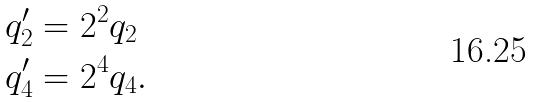Convert formula to latex. <formula><loc_0><loc_0><loc_500><loc_500>q _ { 2 } ^ { \prime } & = 2 ^ { 2 } q _ { 2 } \\ q _ { 4 } ^ { \prime } & = 2 ^ { 4 } q _ { 4 } .</formula> 